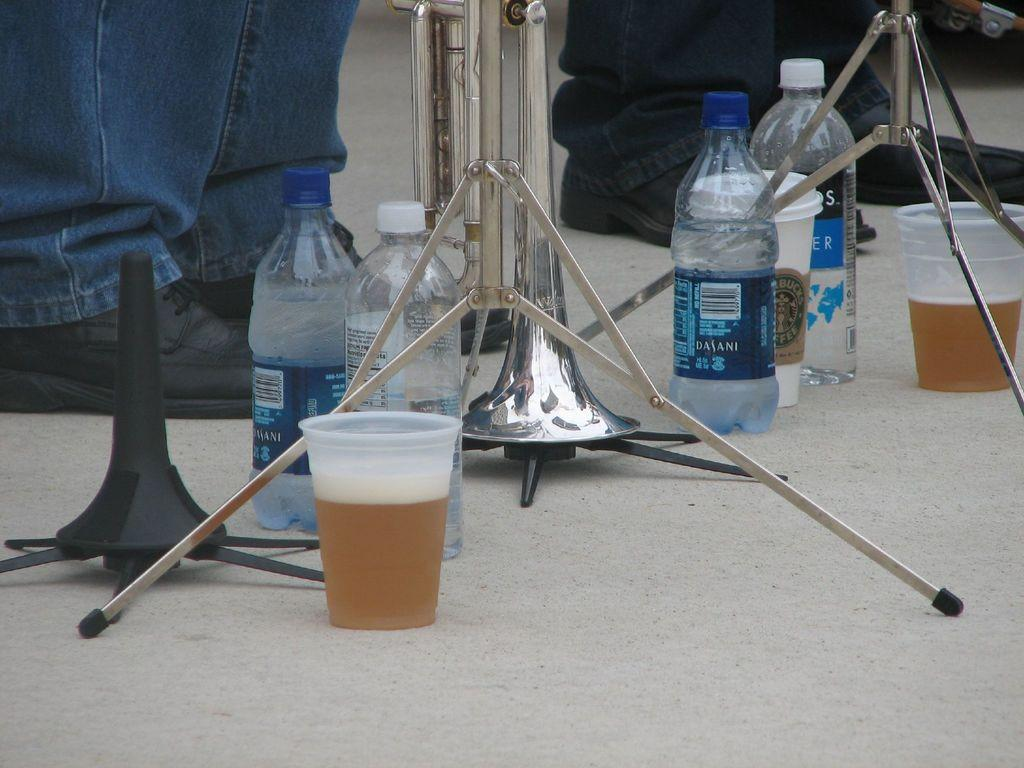<image>
Provide a brief description of the given image. the word Dasani is on a water bottle on the white surface 